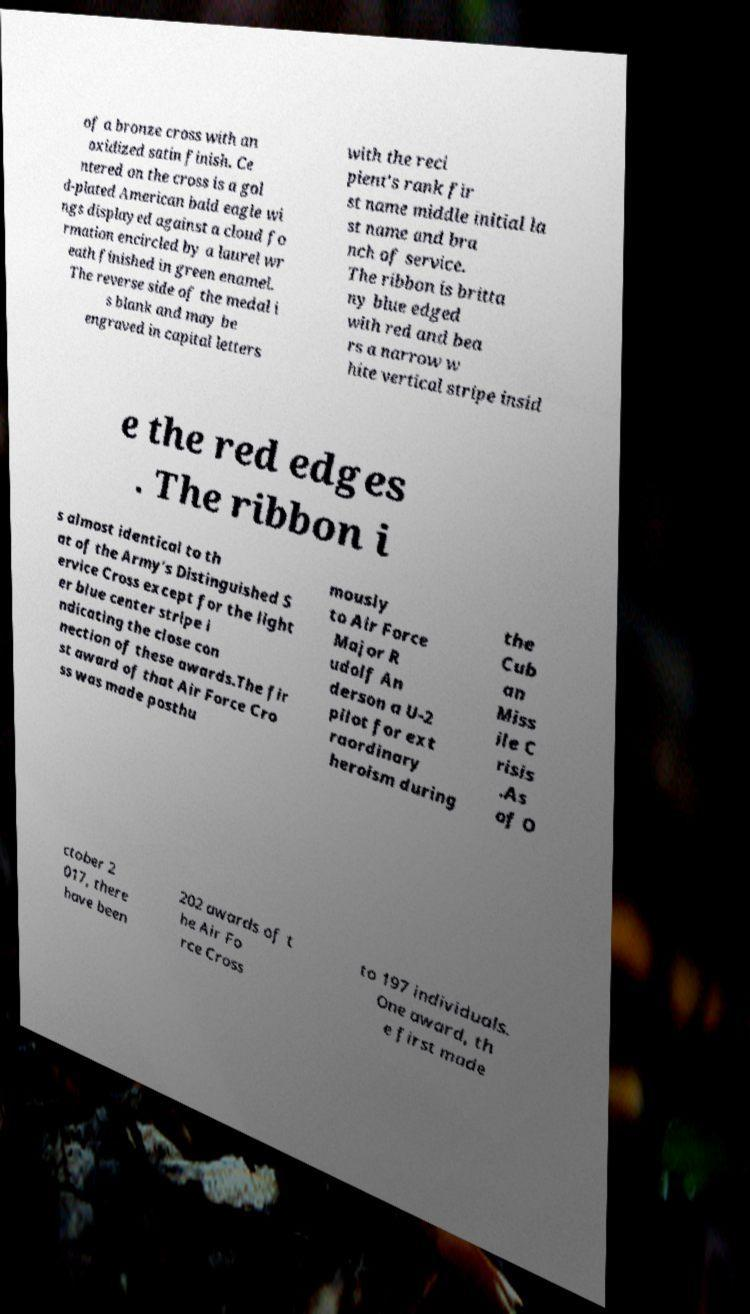There's text embedded in this image that I need extracted. Can you transcribe it verbatim? of a bronze cross with an oxidized satin finish. Ce ntered on the cross is a gol d-plated American bald eagle wi ngs displayed against a cloud fo rmation encircled by a laurel wr eath finished in green enamel. The reverse side of the medal i s blank and may be engraved in capital letters with the reci pient's rank fir st name middle initial la st name and bra nch of service. The ribbon is britta ny blue edged with red and bea rs a narrow w hite vertical stripe insid e the red edges . The ribbon i s almost identical to th at of the Army's Distinguished S ervice Cross except for the light er blue center stripe i ndicating the close con nection of these awards.The fir st award of that Air Force Cro ss was made posthu mously to Air Force Major R udolf An derson a U-2 pilot for ext raordinary heroism during the Cub an Miss ile C risis .As of O ctober 2 017, there have been 202 awards of t he Air Fo rce Cross to 197 individuals. One award, th e first made 